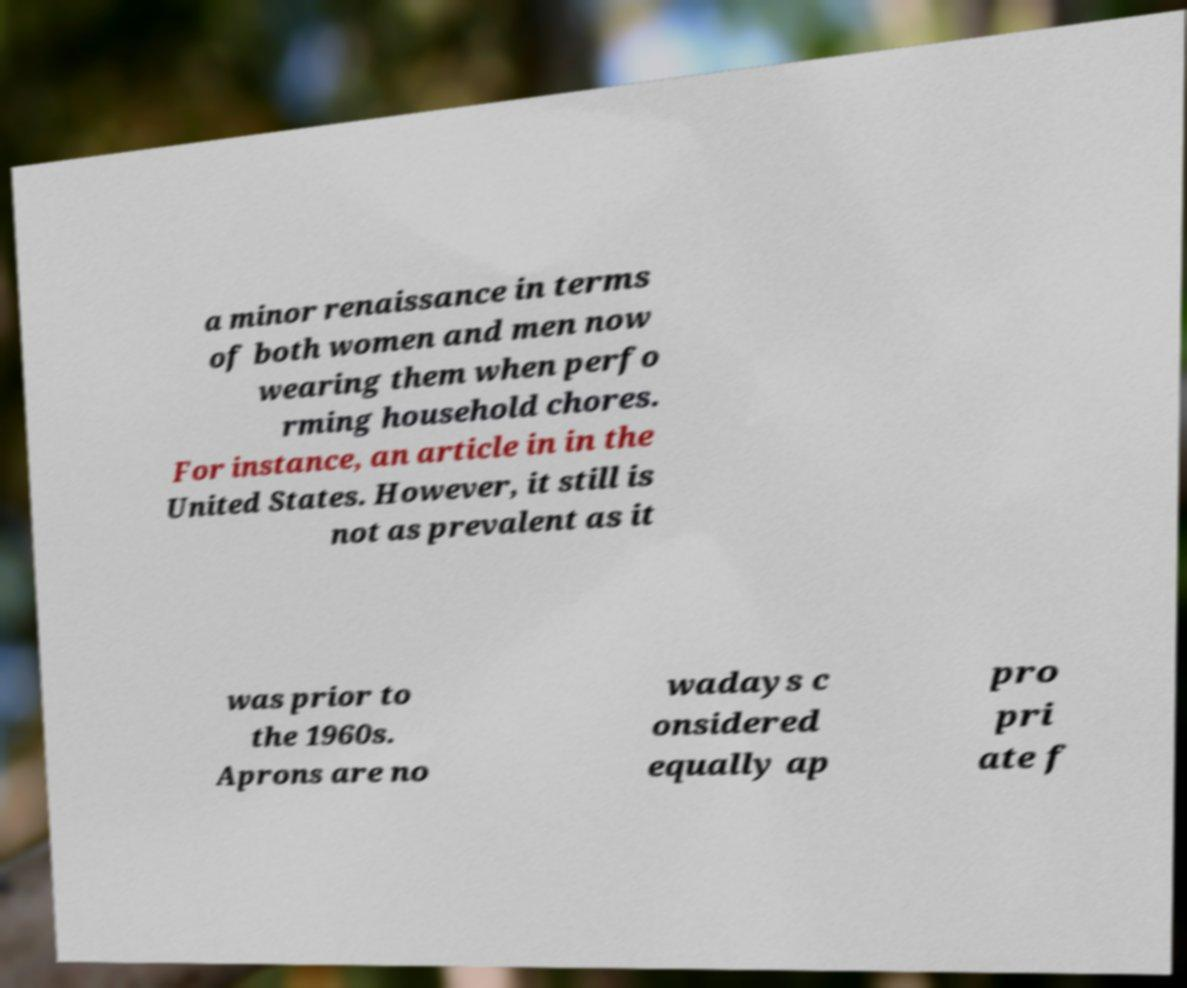Please read and relay the text visible in this image. What does it say? a minor renaissance in terms of both women and men now wearing them when perfo rming household chores. For instance, an article in in the United States. However, it still is not as prevalent as it was prior to the 1960s. Aprons are no wadays c onsidered equally ap pro pri ate f 